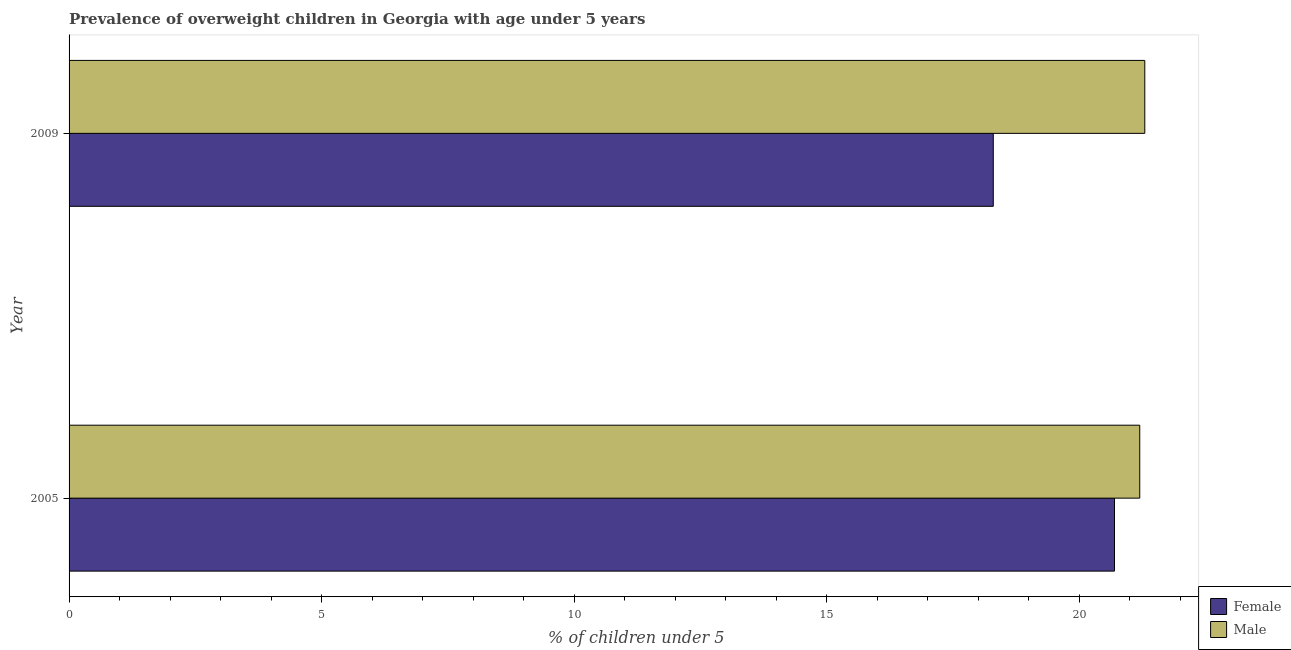How many different coloured bars are there?
Keep it short and to the point. 2. What is the percentage of obese female children in 2005?
Your response must be concise. 20.7. Across all years, what is the maximum percentage of obese male children?
Offer a terse response. 21.3. Across all years, what is the minimum percentage of obese male children?
Ensure brevity in your answer.  21.2. What is the total percentage of obese male children in the graph?
Your answer should be compact. 42.5. What is the difference between the percentage of obese female children in 2009 and the percentage of obese male children in 2005?
Your response must be concise. -2.9. What is the average percentage of obese male children per year?
Give a very brief answer. 21.25. In the year 2009, what is the difference between the percentage of obese female children and percentage of obese male children?
Your answer should be very brief. -3. In how many years, is the percentage of obese male children greater than 11 %?
Provide a succinct answer. 2. What is the ratio of the percentage of obese female children in 2005 to that in 2009?
Keep it short and to the point. 1.13. Is the difference between the percentage of obese male children in 2005 and 2009 greater than the difference between the percentage of obese female children in 2005 and 2009?
Ensure brevity in your answer.  No. What does the 2nd bar from the top in 2005 represents?
Your response must be concise. Female. How many bars are there?
Offer a terse response. 4. Are all the bars in the graph horizontal?
Ensure brevity in your answer.  Yes. Are the values on the major ticks of X-axis written in scientific E-notation?
Your response must be concise. No. Does the graph contain any zero values?
Keep it short and to the point. No. Does the graph contain grids?
Provide a short and direct response. No. Where does the legend appear in the graph?
Provide a succinct answer. Bottom right. How many legend labels are there?
Your answer should be compact. 2. What is the title of the graph?
Offer a terse response. Prevalence of overweight children in Georgia with age under 5 years. What is the label or title of the X-axis?
Ensure brevity in your answer.   % of children under 5. What is the label or title of the Y-axis?
Your answer should be very brief. Year. What is the  % of children under 5 of Female in 2005?
Your answer should be compact. 20.7. What is the  % of children under 5 of Male in 2005?
Keep it short and to the point. 21.2. What is the  % of children under 5 in Female in 2009?
Your response must be concise. 18.3. What is the  % of children under 5 in Male in 2009?
Make the answer very short. 21.3. Across all years, what is the maximum  % of children under 5 of Female?
Give a very brief answer. 20.7. Across all years, what is the maximum  % of children under 5 in Male?
Offer a very short reply. 21.3. Across all years, what is the minimum  % of children under 5 in Female?
Provide a succinct answer. 18.3. Across all years, what is the minimum  % of children under 5 of Male?
Provide a short and direct response. 21.2. What is the total  % of children under 5 in Female in the graph?
Your response must be concise. 39. What is the total  % of children under 5 of Male in the graph?
Ensure brevity in your answer.  42.5. What is the difference between the  % of children under 5 in Female in 2005 and that in 2009?
Offer a very short reply. 2.4. What is the difference between the  % of children under 5 in Male in 2005 and that in 2009?
Make the answer very short. -0.1. What is the difference between the  % of children under 5 of Female in 2005 and the  % of children under 5 of Male in 2009?
Provide a short and direct response. -0.6. What is the average  % of children under 5 of Female per year?
Give a very brief answer. 19.5. What is the average  % of children under 5 of Male per year?
Ensure brevity in your answer.  21.25. In the year 2005, what is the difference between the  % of children under 5 in Female and  % of children under 5 in Male?
Your answer should be compact. -0.5. What is the ratio of the  % of children under 5 of Female in 2005 to that in 2009?
Give a very brief answer. 1.13. What is the difference between the highest and the lowest  % of children under 5 in Male?
Ensure brevity in your answer.  0.1. 